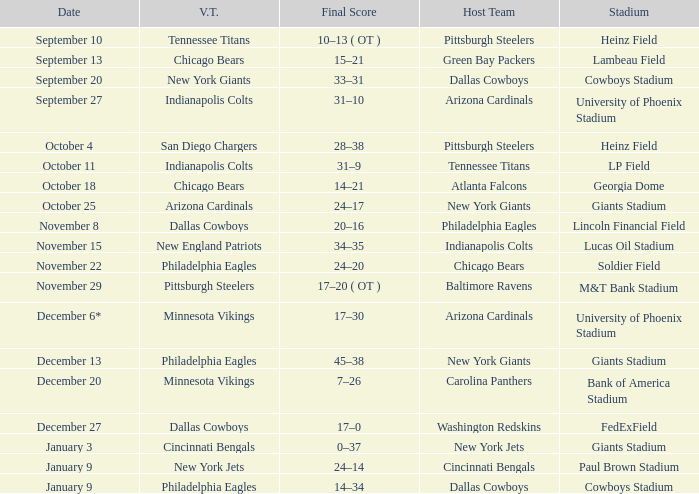Tell me the date for pittsburgh steelers November 29. 